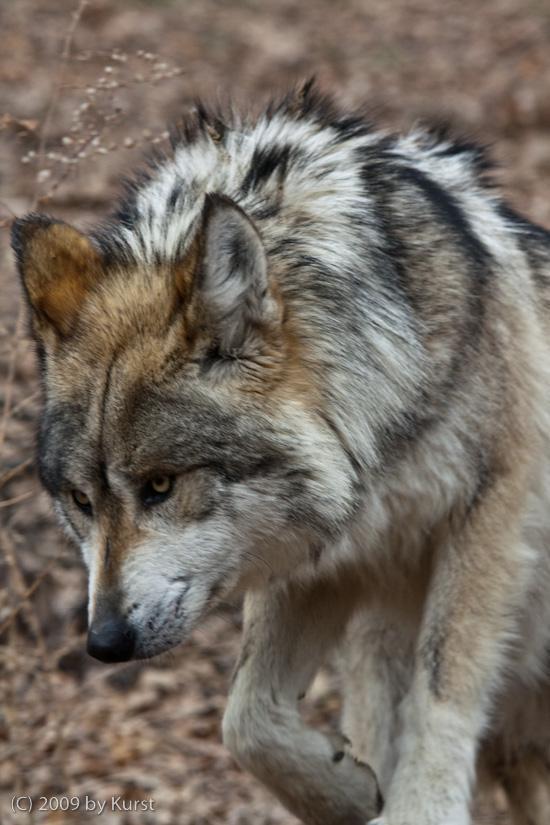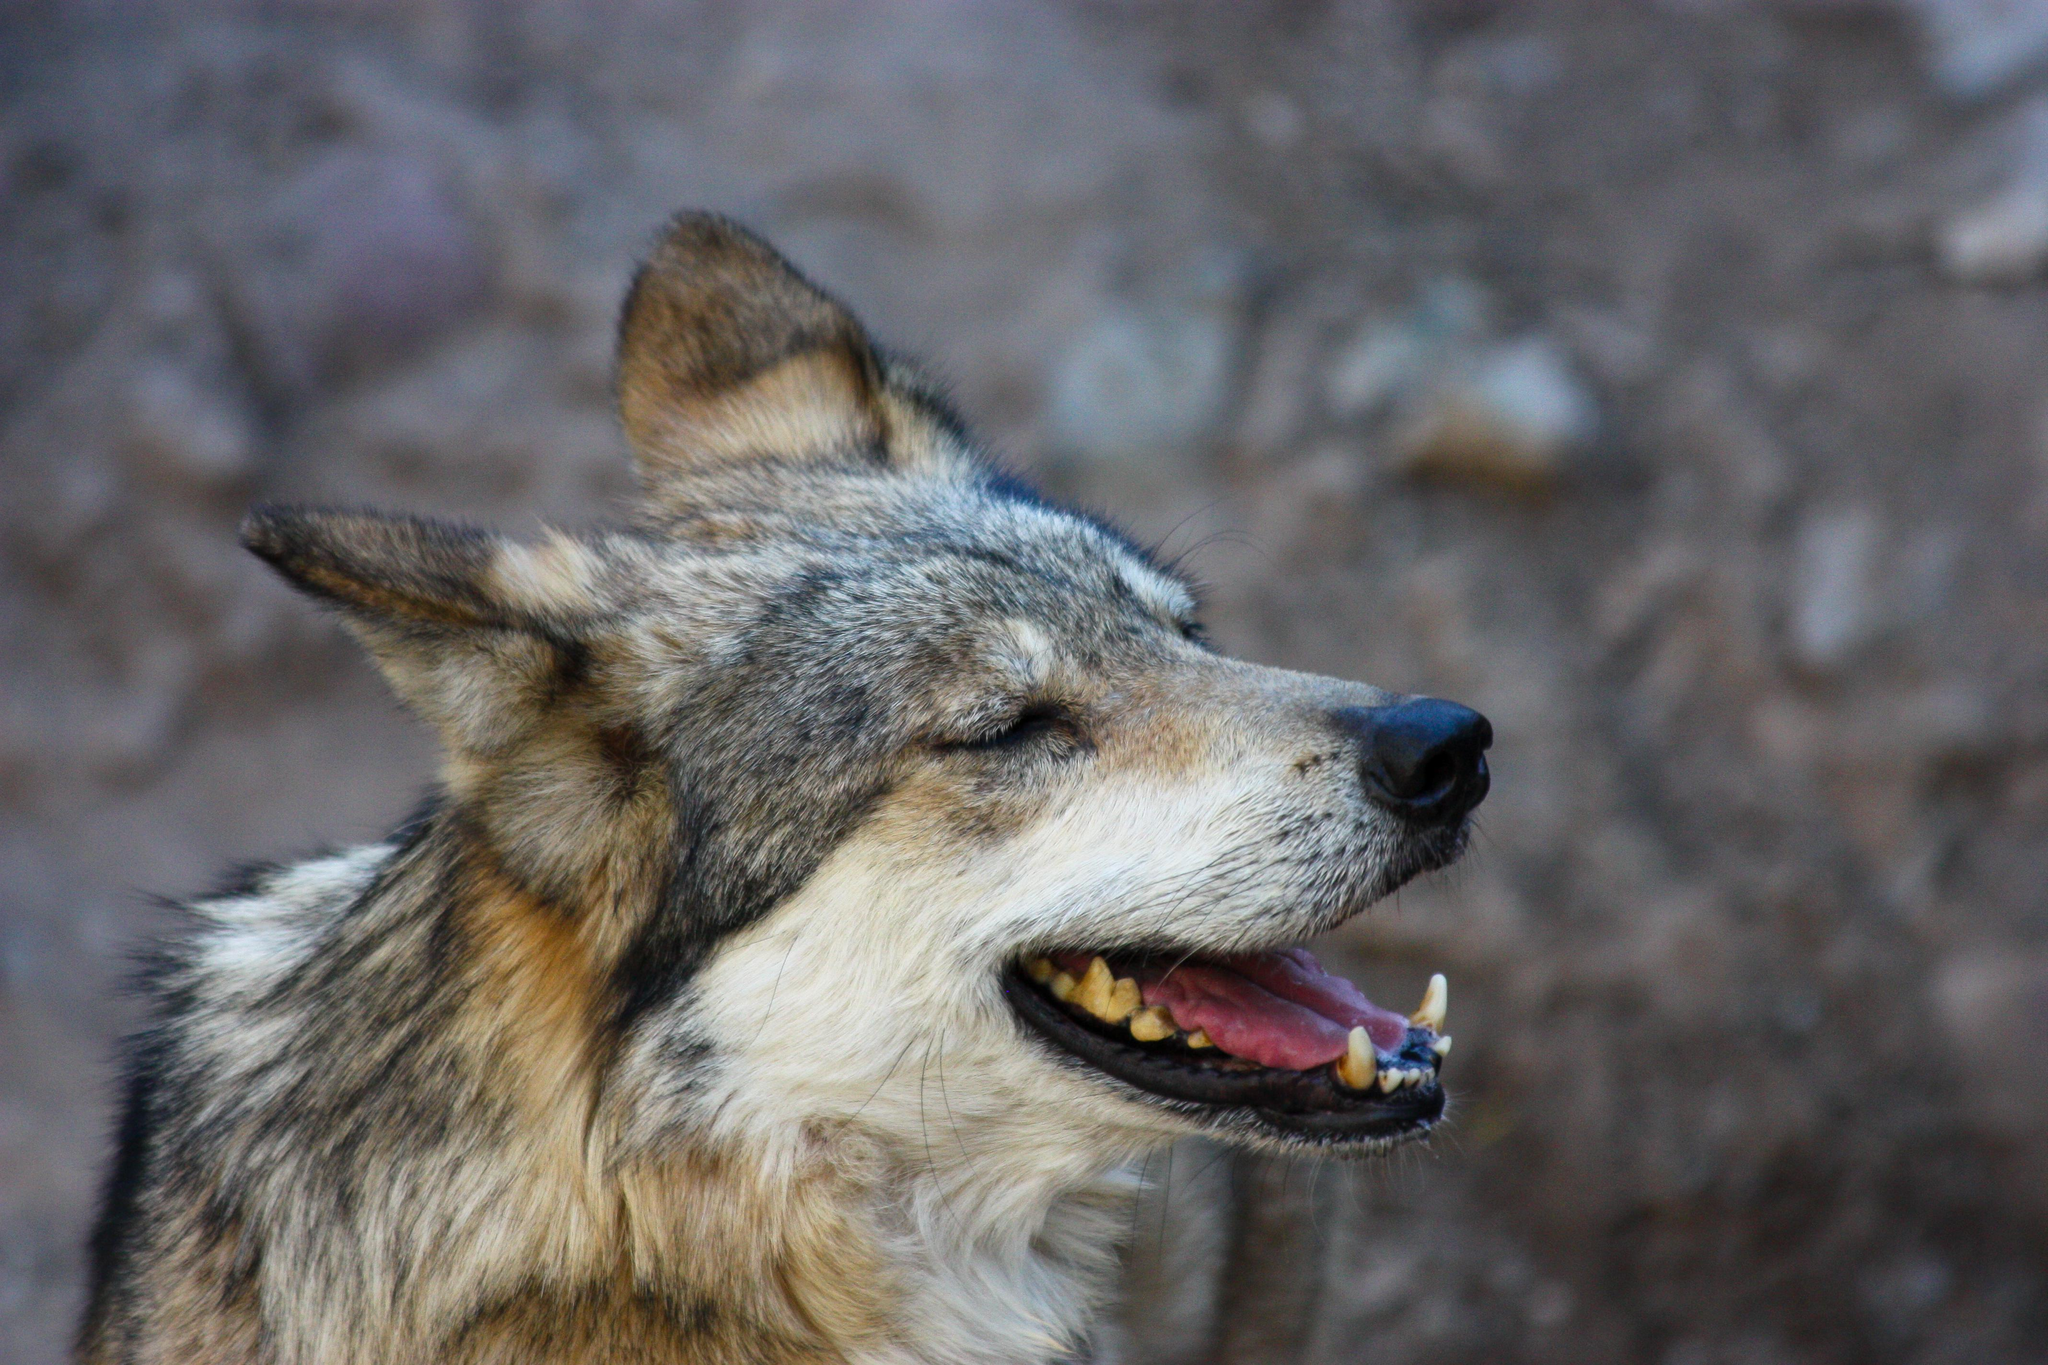The first image is the image on the left, the second image is the image on the right. Examine the images to the left and right. Is the description "in both photos the wolf is facing the same direction" accurate? Answer yes or no. No. The first image is the image on the left, the second image is the image on the right. Considering the images on both sides, is "wolves are facing oposite directions in the image pair" valid? Answer yes or no. Yes. 